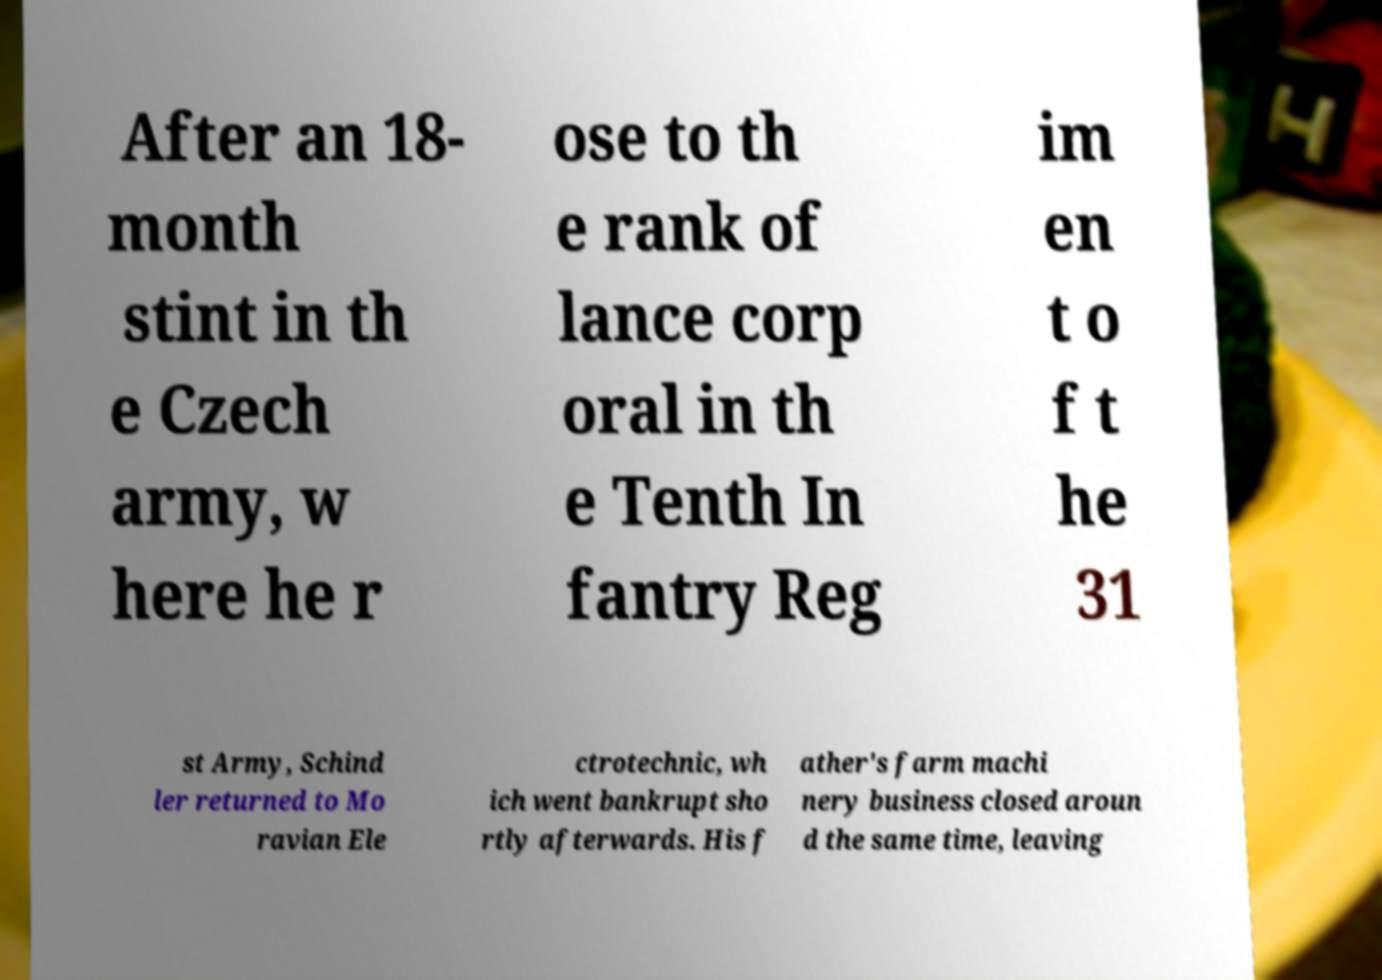There's text embedded in this image that I need extracted. Can you transcribe it verbatim? After an 18- month stint in th e Czech army, w here he r ose to th e rank of lance corp oral in th e Tenth In fantry Reg im en t o f t he 31 st Army, Schind ler returned to Mo ravian Ele ctrotechnic, wh ich went bankrupt sho rtly afterwards. His f ather's farm machi nery business closed aroun d the same time, leaving 